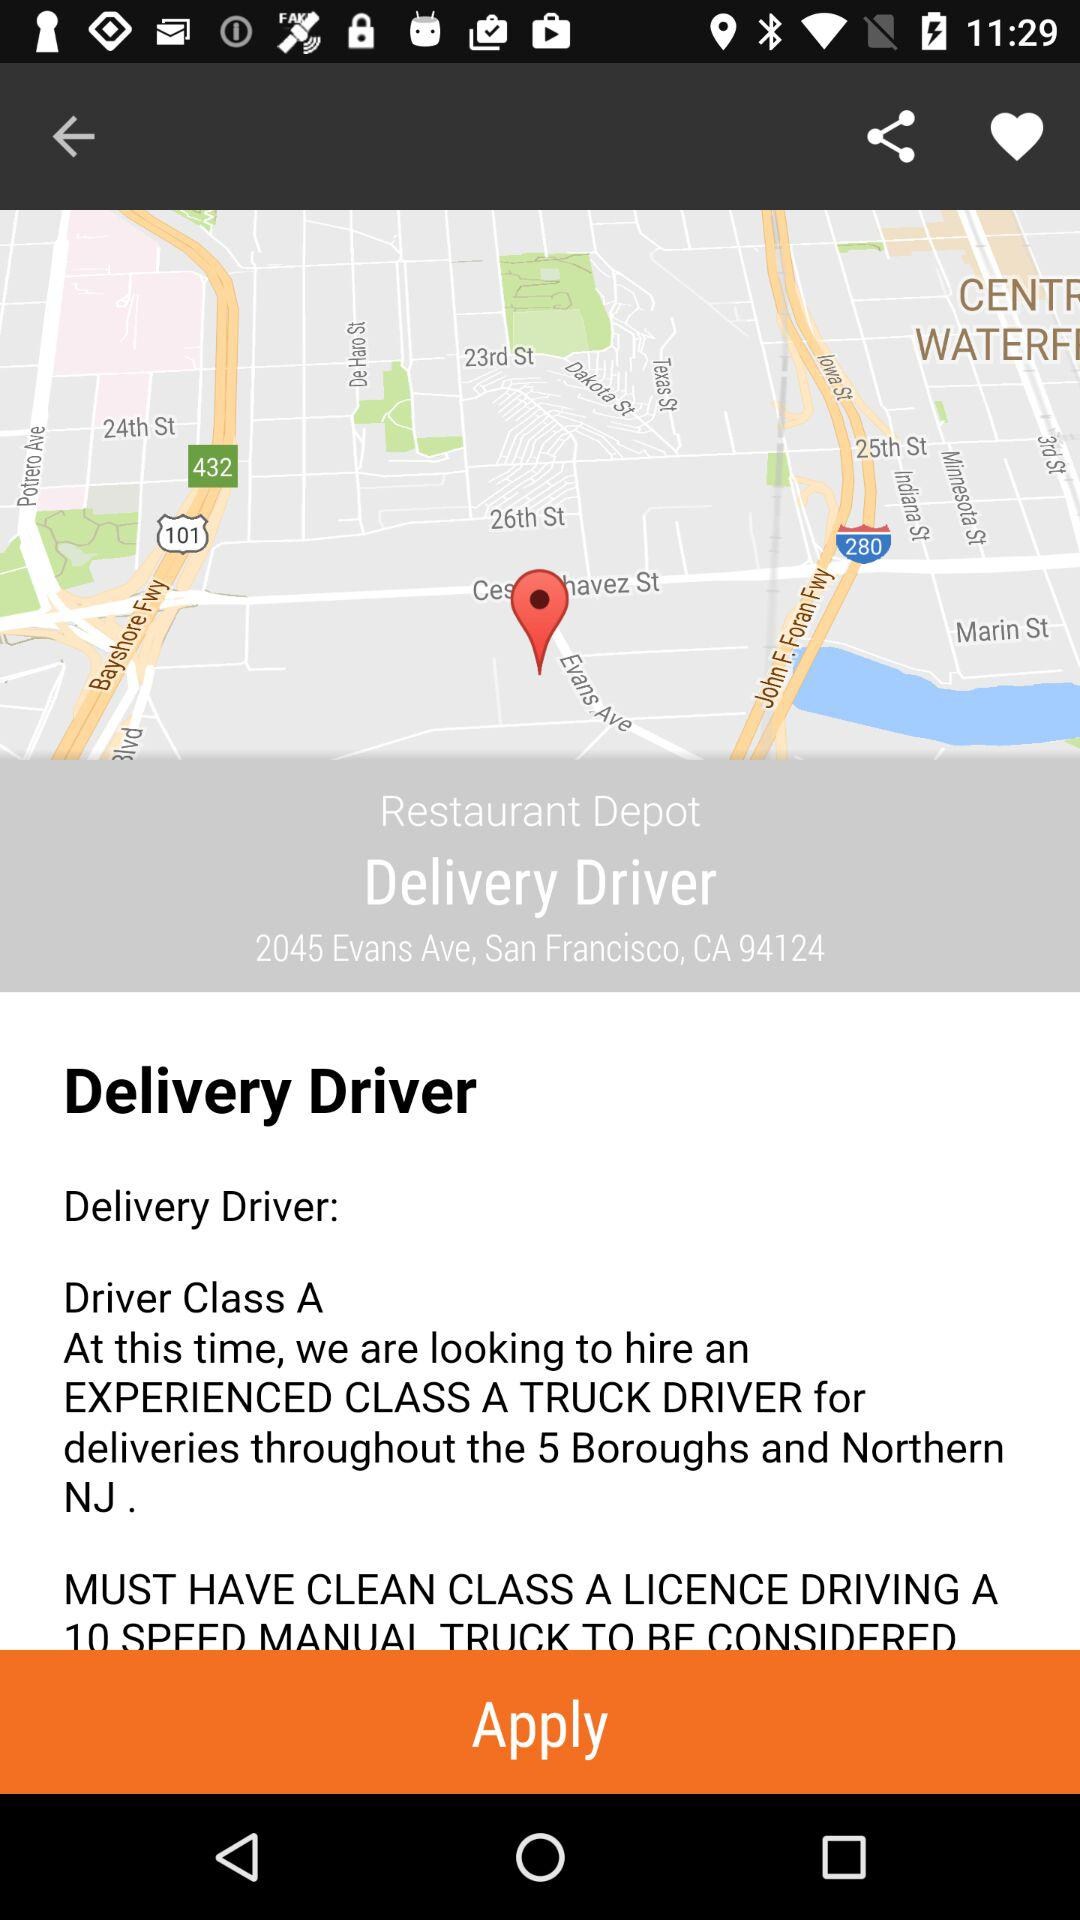What is the delivery address? The delivery address is "2045 Evans Ave, San Francisco, CA 94124". 